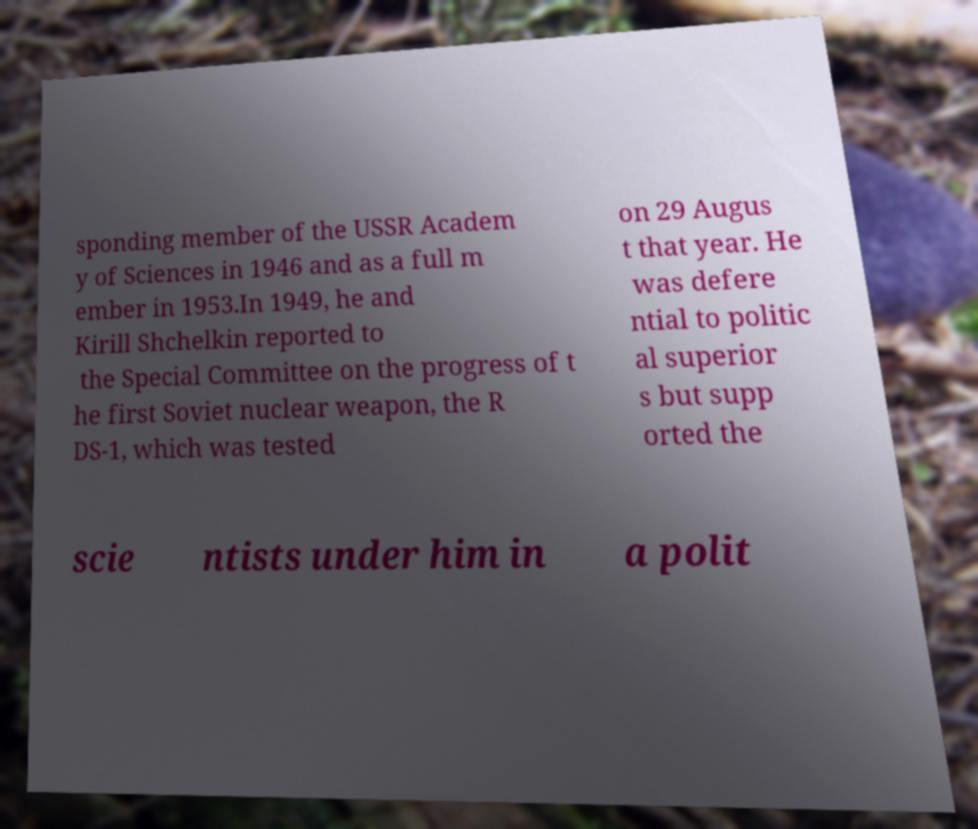Please identify and transcribe the text found in this image. sponding member of the USSR Academ y of Sciences in 1946 and as a full m ember in 1953.In 1949, he and Kirill Shchelkin reported to the Special Committee on the progress of t he first Soviet nuclear weapon, the R DS-1, which was tested on 29 Augus t that year. He was defere ntial to politic al superior s but supp orted the scie ntists under him in a polit 